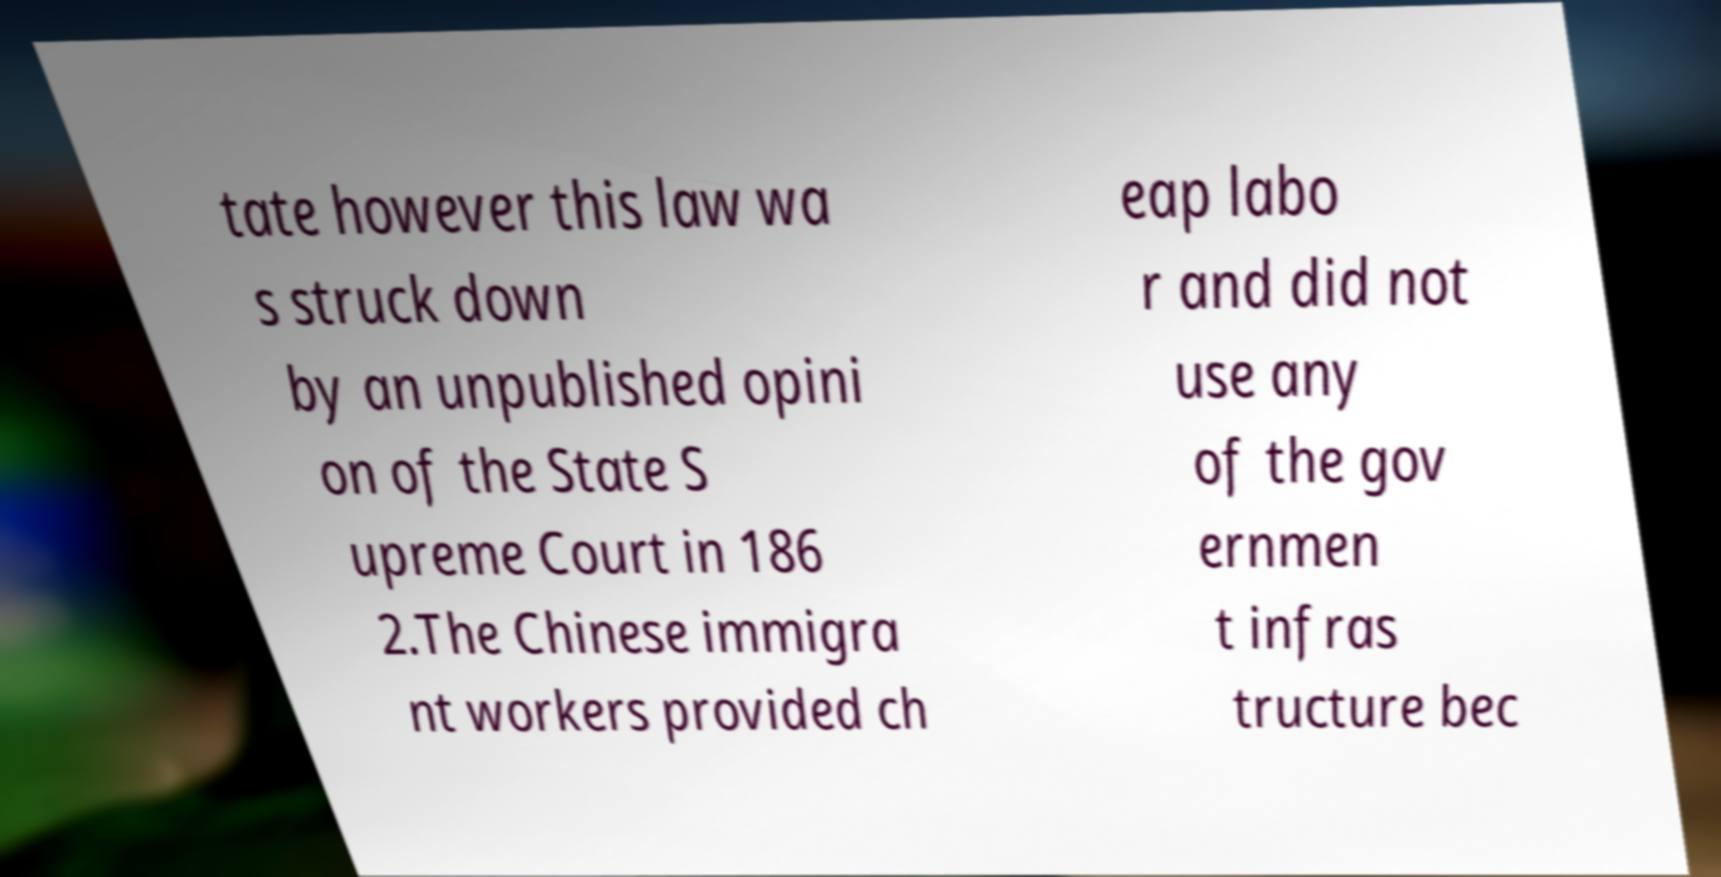What messages or text are displayed in this image? I need them in a readable, typed format. tate however this law wa s struck down by an unpublished opini on of the State S upreme Court in 186 2.The Chinese immigra nt workers provided ch eap labo r and did not use any of the gov ernmen t infras tructure bec 